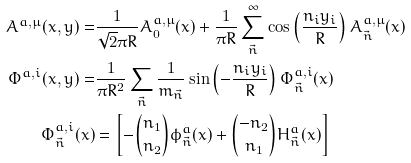Convert formula to latex. <formula><loc_0><loc_0><loc_500><loc_500>A ^ { a , \mu } ( x , y ) = & \frac { 1 } { \sqrt { 2 } \pi R } A ^ { a , \mu } _ { 0 } ( x ) + \frac { 1 } { \pi R } \sum _ { \vec { n } } ^ { \infty } \cos \left ( \frac { n _ { i } y _ { i } } { R } \right ) A ^ { a , \mu } _ { \vec { n } } ( x ) \\ \Phi ^ { a , i } ( x , y ) = & \frac { 1 } { \pi R ^ { 2 } } \sum _ { \vec { n } } \frac { 1 } { m _ { \vec { n } } } \sin \left ( - \frac { n _ { i } y _ { i } } { R } \right ) \Phi ^ { a , i } _ { \vec { n } } ( x ) \\ \Phi ^ { a , i } _ { \vec { n } } ( x ) & = \left [ - \binom { n _ { 1 } } { n _ { 2 } } \phi ^ { a } _ { \vec { n } } ( x ) + \binom { - n _ { 2 } } { n _ { 1 } } H ^ { a } _ { \vec { n } } ( x ) \right ]</formula> 